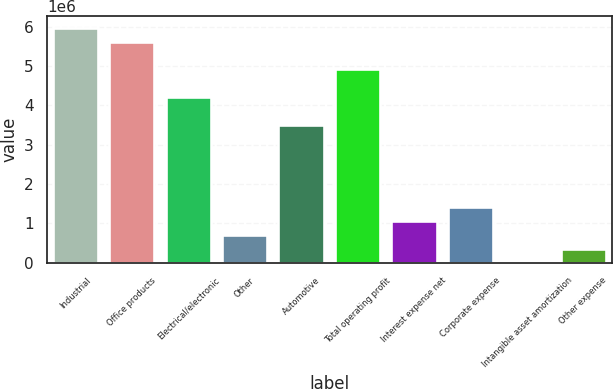<chart> <loc_0><loc_0><loc_500><loc_500><bar_chart><fcel>Industrial<fcel>Office products<fcel>Electrical/electronic<fcel>Other<fcel>Automotive<fcel>Total operating profit<fcel>Interest expense net<fcel>Corporate expense<fcel>Intangible asset amortization<fcel>Other expense<nl><fcel>5.97292e+06<fcel>5.62174e+06<fcel>4.21702e+06<fcel>705221<fcel>3.51466e+06<fcel>4.91938e+06<fcel>1.0564e+06<fcel>1.40758e+06<fcel>2861<fcel>354041<nl></chart> 